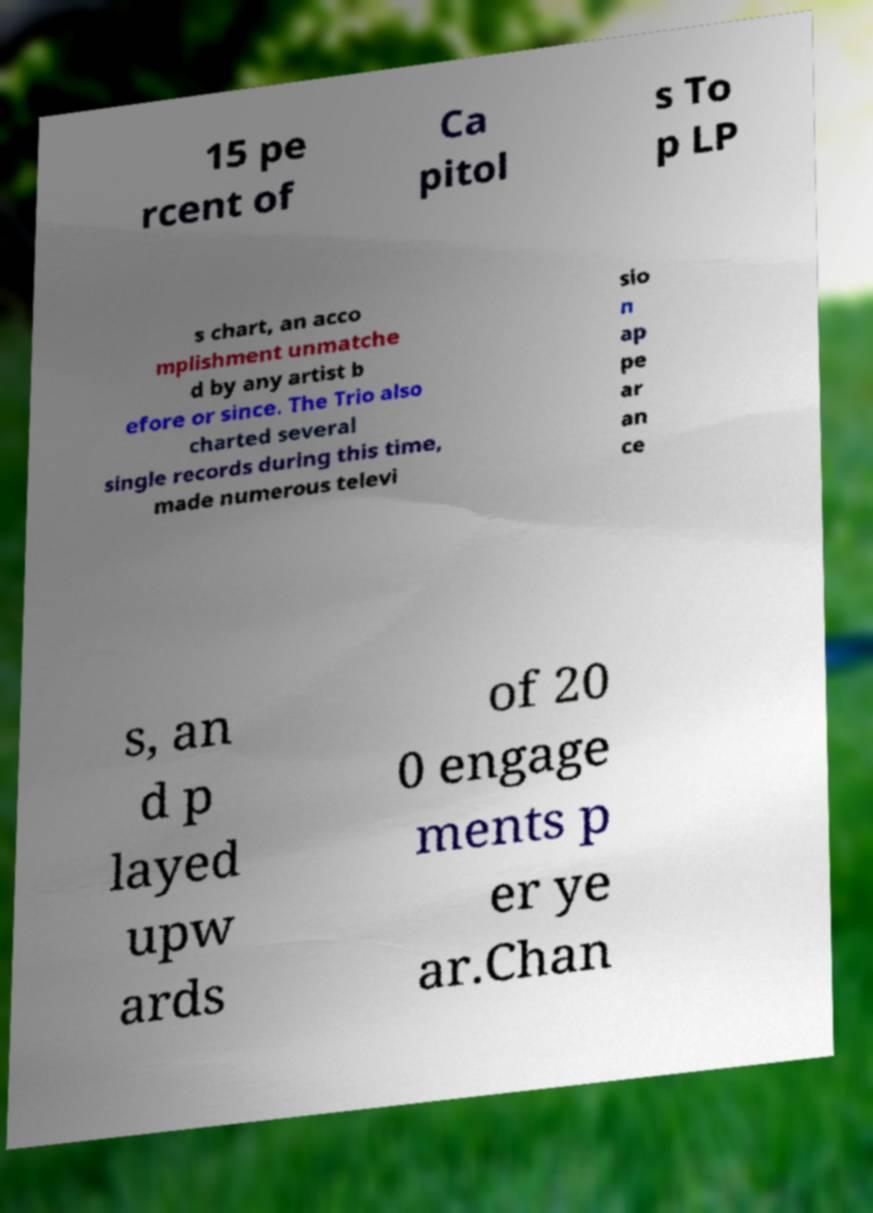Can you accurately transcribe the text from the provided image for me? 15 pe rcent of Ca pitol s To p LP s chart, an acco mplishment unmatche d by any artist b efore or since. The Trio also charted several single records during this time, made numerous televi sio n ap pe ar an ce s, an d p layed upw ards of 20 0 engage ments p er ye ar.Chan 